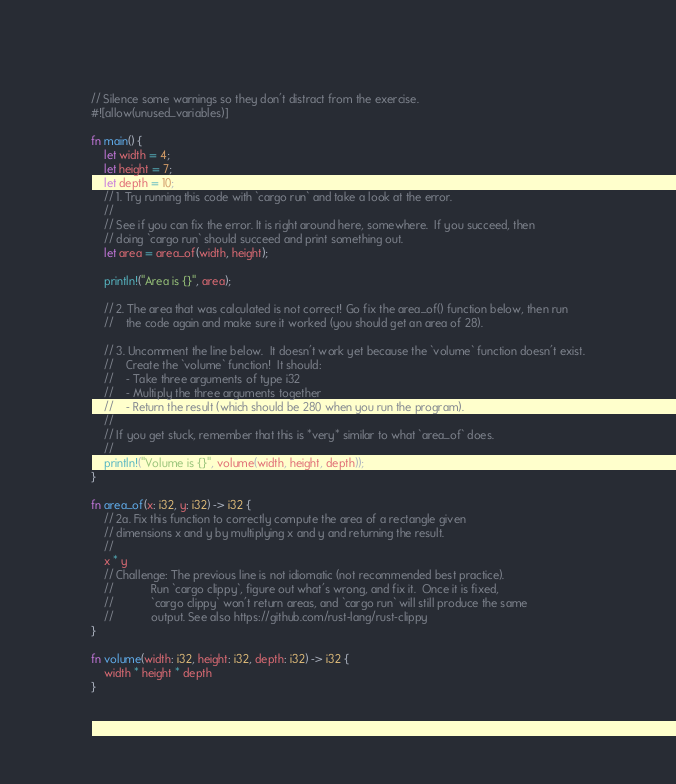Convert code to text. <code><loc_0><loc_0><loc_500><loc_500><_Rust_>// Silence some warnings so they don't distract from the exercise.
#![allow(unused_variables)]

fn main() {
    let width = 4;
    let height = 7;
    let depth = 10;
    // 1. Try running this code with `cargo run` and take a look at the error.
    //
    // See if you can fix the error. It is right around here, somewhere.  If you succeed, then
    // doing `cargo run` should succeed and print something out.
    let area = area_of(width, height);

    println!("Area is {}", area);

    // 2. The area that was calculated is not correct! Go fix the area_of() function below, then run
    //    the code again and make sure it worked (you should get an area of 28).

    // 3. Uncomment the line below.  It doesn't work yet because the `volume` function doesn't exist.
    //    Create the `volume` function!  It should:
    //    - Take three arguments of type i32
    //    - Multiply the three arguments together
    //    - Return the result (which should be 280 when you run the program).
    //
    // If you get stuck, remember that this is *very* similar to what `area_of` does.
    //
    println!("Volume is {}", volume(width, height, depth));
}

fn area_of(x: i32, y: i32) -> i32 {
    // 2a. Fix this function to correctly compute the area of a rectangle given
    // dimensions x and y by multiplying x and y and returning the result.
    //
    x * y
    // Challenge: The previous line is not idiomatic (not recommended best practice).
    //            Run `cargo clippy`, figure out what's wrong, and fix it.  Once it is fixed,
    //            `cargo clippy` won't return areas, and `cargo run` will still produce the same
    //            output. See also https://github.com/rust-lang/rust-clippy
}

fn volume(width: i32, height: i32, depth: i32) -> i32 {
    width * height * depth
}</code> 